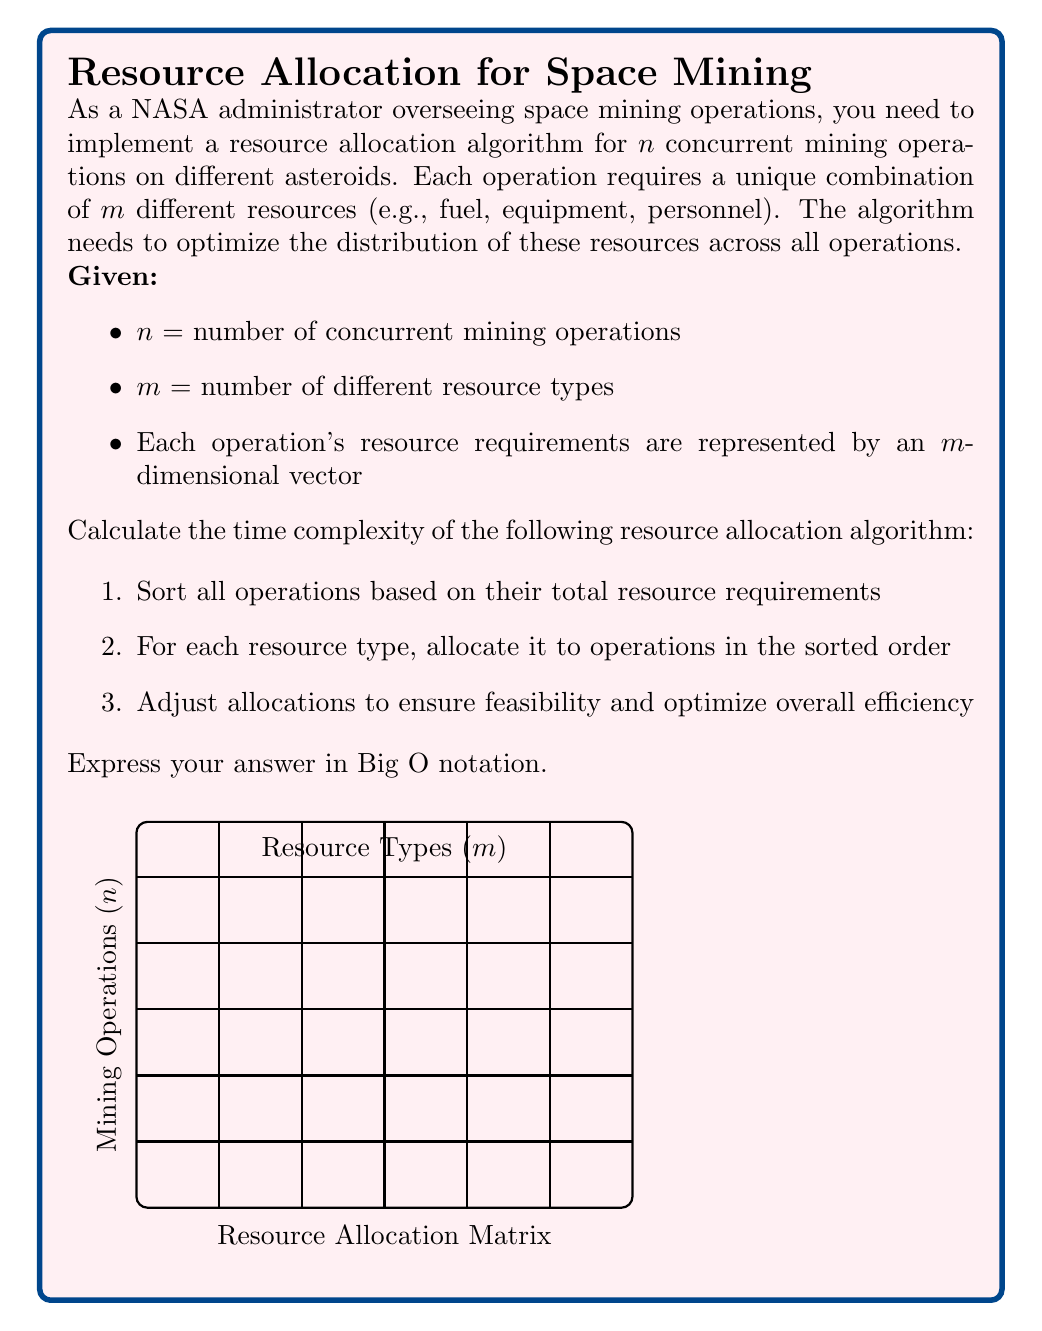Can you solve this math problem? Let's break down the algorithm and analyze its time complexity step by step:

1. Sorting operations based on total resource requirements:
   - Calculating total requirements for each operation: $O(nm)$
   - Sorting $n$ operations: $O(n \log n)$ using an efficient sorting algorithm
   Total for step 1: $O(nm + n \log n)$

2. Allocating resources for each type:
   - We have $m$ resource types
   - For each type, we iterate through $n$ sorted operations
   Total for step 2: $O(mn)$

3. Adjusting allocations:
   - In the worst case, we might need to iterate through all operations for each resource type
   Total for step 3: $O(mn)$

Now, let's combine these steps:

$$O(nm + n \log n + mn + mn)$$

Simplifying:
$$O(nm + n \log n + 2mn)$$
$$O(nm + n \log n)$$

To determine the dominant term, we need to compare $nm$ and $n \log n$:

- If $m > \log n$, then $nm$ dominates
- If $m < \log n$, then $n \log n$ dominates
- If $m = \log n$, both terms are equally significant

In the context of space mining, it's likely that the number of resource types ($m$) is significantly smaller than the number of mining operations ($n$). Therefore, we can assume $m < \log n$ for large values of $n$.

Under this assumption, the time complexity of the algorithm is $O(n \log n)$.
Answer: $O(n \log n)$ 